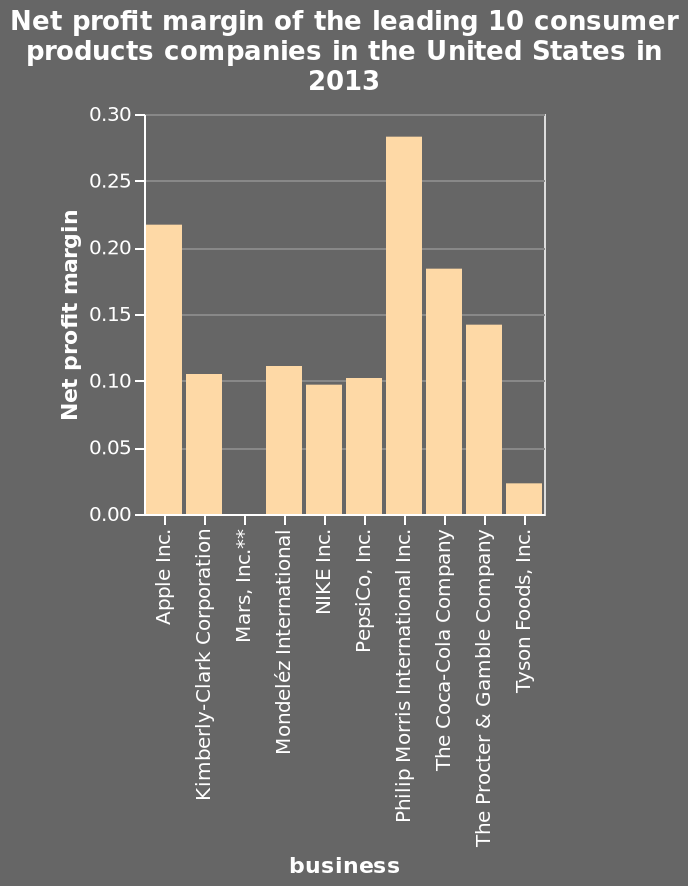<image>
Offer a thorough analysis of the image. Philip Morris international had the highest net profit margin. Among the companies mentioned, which one achieved the highest profitability? Philip Morris International achieved the highest profitability. What year is the data from? The data is from the year 2013. 